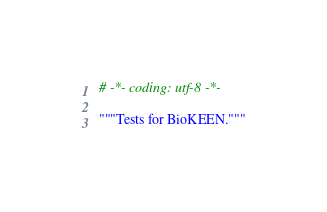Convert code to text. <code><loc_0><loc_0><loc_500><loc_500><_Python_># -*- coding: utf-8 -*-

"""Tests for BioKEEN."""
</code> 